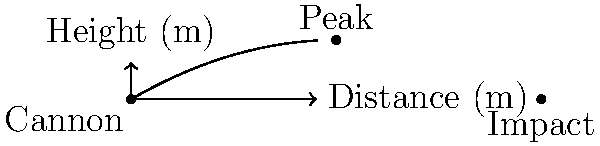As a gunner aboard HMS Victory, you're tasked with hitting an enemy ship 80 meters away. The cannon is fired at an angle of 30° to the horizontal with an initial velocity of 50 m/s. Assuming no air resistance, will the cannonball hit the target? If not, how far beyond or short of the target will it land? Let's approach this step-by-step:

1) First, we need to calculate the range of the cannonball. The range formula is:

   $$R = \frac{v_0^2 \sin(2\theta)}{g}$$

   Where $v_0$ is the initial velocity, $\theta$ is the angle, and $g$ is the acceleration due to gravity (9.8 m/s²).

2) We have:
   $v_0 = 50$ m/s
   $\theta = 30° = \pi/6$ radians
   $g = 9.8$ m/s²

3) Plugging these into our equation:

   $$R = \frac{50^2 \sin(2\pi/6)}{9.8} = \frac{2500 \sin(\pi/3)}{9.8} = \frac{2500 \cdot \sqrt{3}/2}{9.8} \approx 220.8 \text{ m}$$

4) The cannonball will travel approximately 220.8 meters.

5) The target is 80 meters away, so the cannonball will overshoot the target by:

   $$220.8 - 80 = 140.8 \text{ meters}$$
Answer: No, overshoots by 140.8 m 